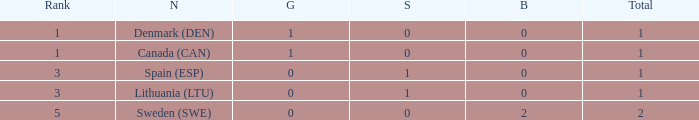How many bronze medals were won when the total is more than 1, and gold is more than 0? None. 